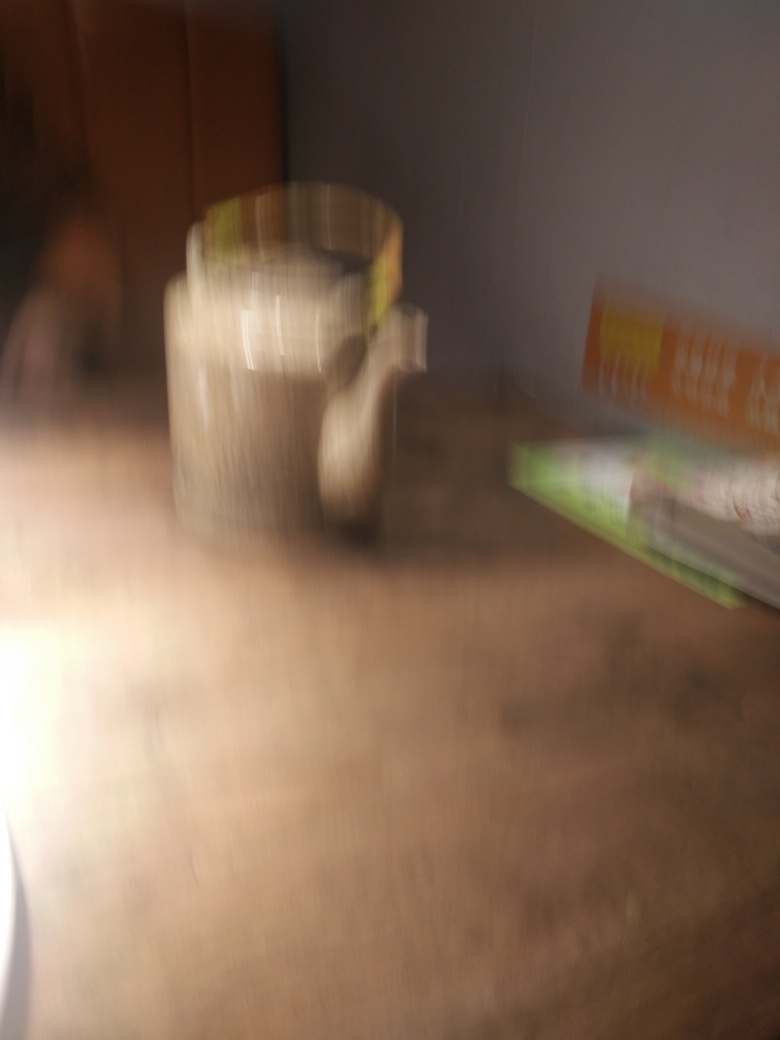Is the subject of the image blurry? Yes, the subject of the image is indeed blurry. The lack of sharpness in the image prevents a clear identification of the objects, which could be due to motion during the capture or an out-of-focus camera setting. 